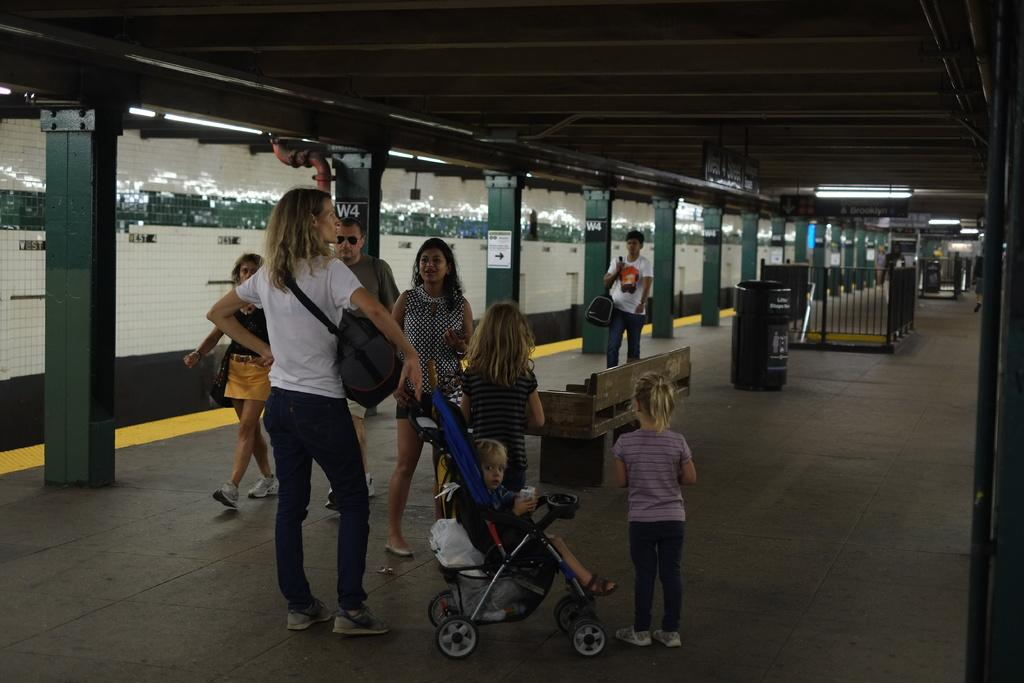How many people are in the group visible in the image? The number of people in the group cannot be determined from the image, but there is a group of people standing in the image. What is the kid in the image sitting in? The kid is in a stroller in the image. What type of objects can be seen in the image that are used for displaying information or advertisements? There are boards in the image. What type of objects can be seen in the image that provide illumination? There are lights in the image. What type of objects can be seen in the image that are used for waste disposal? There are dustbins in the image. What type of objects can be seen in the image that provide security or enclosure? There are iron grilles in the image. What type of object can be seen in the image that is used for sitting? There is a bench in the image. What type of objects can be seen in the image that provide support and structure? There are pillars in the image. What type of pen can be seen in the image? There is no pen present in the image. What type of patch can be seen on the kid's clothing in the image? There is no patch visible on the kid's clothing in the image. 